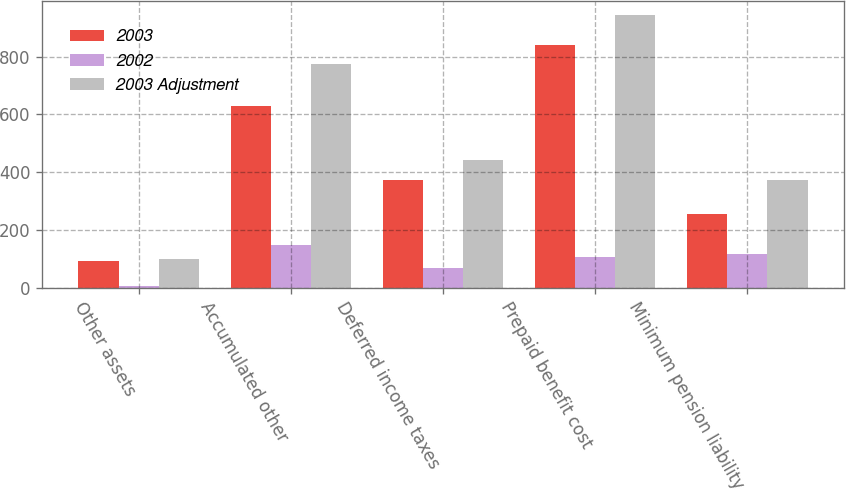Convert chart. <chart><loc_0><loc_0><loc_500><loc_500><stacked_bar_chart><ecel><fcel>Other assets<fcel>Accumulated other<fcel>Deferred income taxes<fcel>Prepaid benefit cost<fcel>Minimum pension liability<nl><fcel>2003<fcel>94<fcel>628<fcel>373<fcel>840<fcel>255<nl><fcel>2002<fcel>7<fcel>147<fcel>69<fcel>105<fcel>118<nl><fcel>2003 Adjustment<fcel>101<fcel>775<fcel>442<fcel>945<fcel>373<nl></chart> 